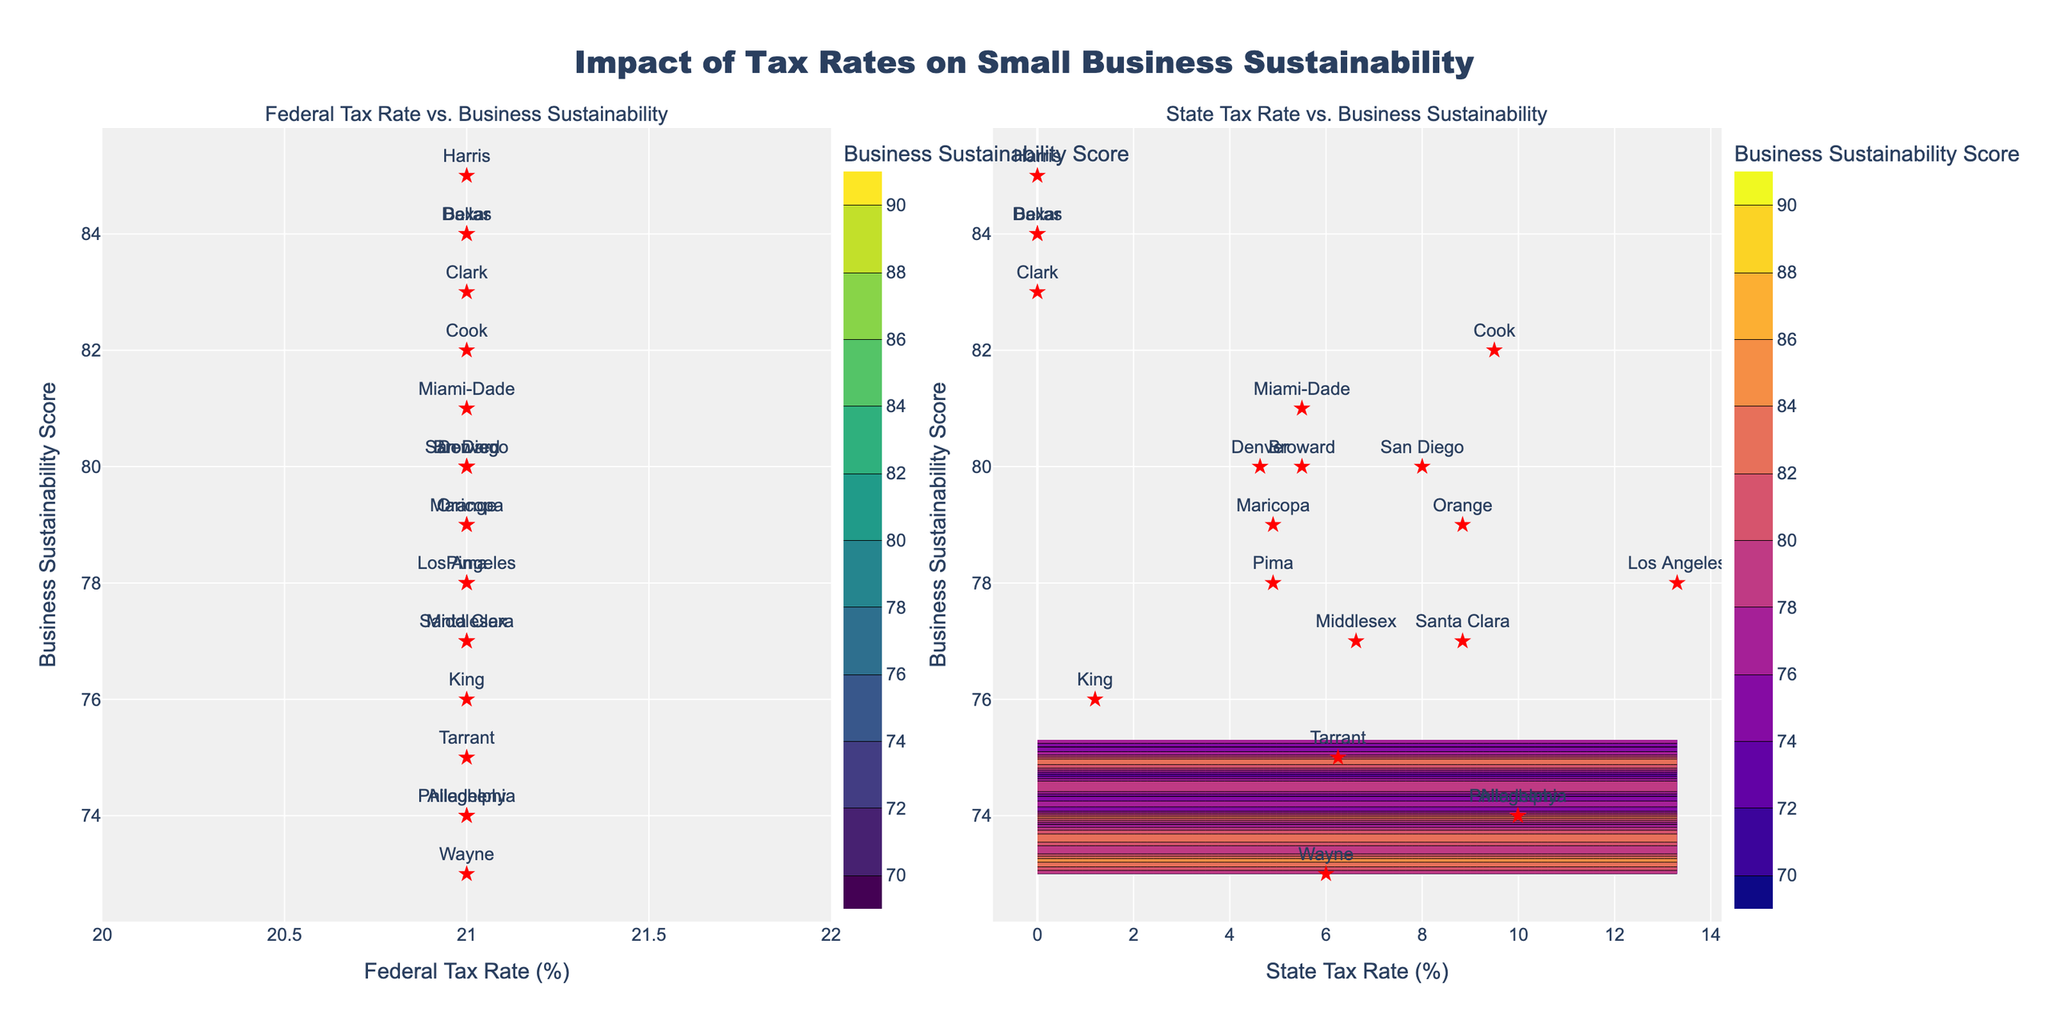What is the title of the figure? The title is written at the top of the figure in large, bold text.
Answer: Impact of Tax Rates on Small Business Sustainability What is the range of the Federal Tax Rate in the left subplot? The Federal Tax Rate is shown on the x-axis of the left subplot with the range labeled at the ends of the axis.
Answer: 21% Which subplot uses the "Viridis" colorscale? The colorscale name is specified in the contour properties, and we can assume it is mentioned in the figure based on the provided data.
Answer: The left subplot How many counties are represented in this figure? Each county is marked with a red star and labeled with its name. Count all the labeled points.
Answer: 20 Which county has the highest Business Sustainability Score? Look for the red markers with the names of the counties. Find the one with the highest vertical position (highest y-axis value).
Answer: Harris What is the Business Sustainability Score for Middlesex County? Find the red star labeled "Middlesex" and read its y-axis value.
Answer: 77 Compare the Business Sustainability Scores of Denver and Philadelphia. Which one is higher? Locate both counties on the plots and compare their y-axis positions.
Answer: Denver What is the Business Sustainability Score for counties with a 0% State Tax Rate? Identify the red stars on the right subplot at the 0 value on the x-axis and note their y-axis values.
Answer: 85 (Harris), 84 (Dallas, Bexar), 83 (Clark) Which subplot investigates the relationship between State Tax Rate and Business Sustainability Score? The title of the subplot and x-axis label will indicate the type of tax rate being analyzed.
Answer: The right subplot How does the Business Sustainability Score trend as the State Tax Rate increases from 0% to around 10%? Observe the general pattern of the contour lines and the plotted points in the right subplot.
Answer: Generally decreases 